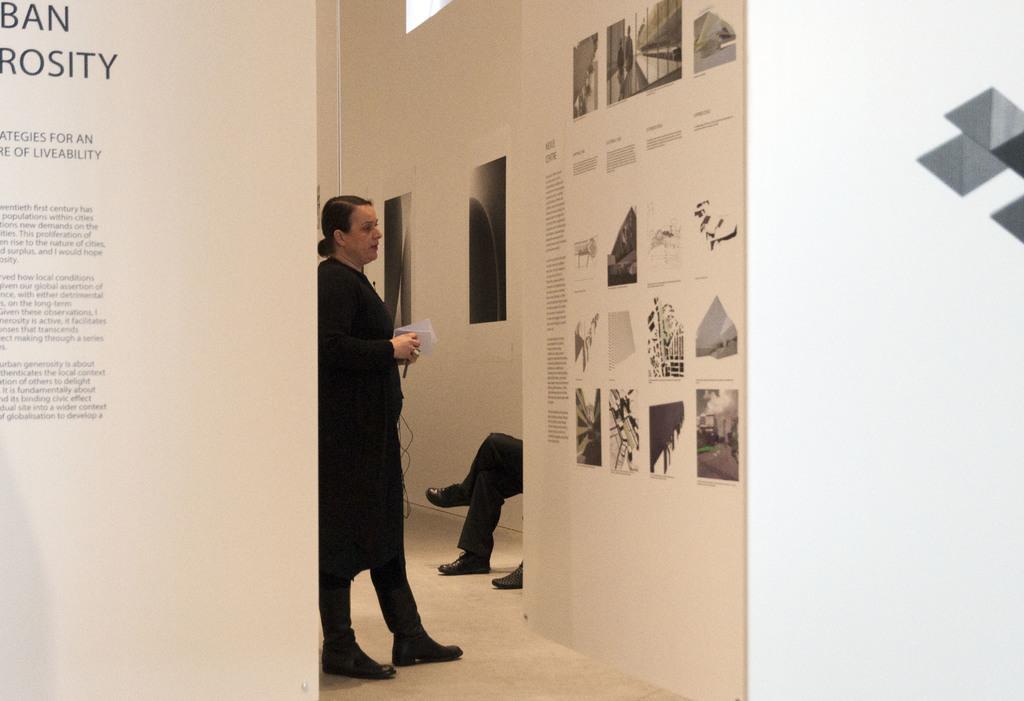Could you give a brief overview of what you see in this image? This is the picture of a room. In this image there is a woman standing and holding the object and there are two people sitting. On the left side of the image there is text on the board. On the right side of the image there is text and there are pictures on the board. At the back there are boards on the wall. At the top there is a ventilator window. 